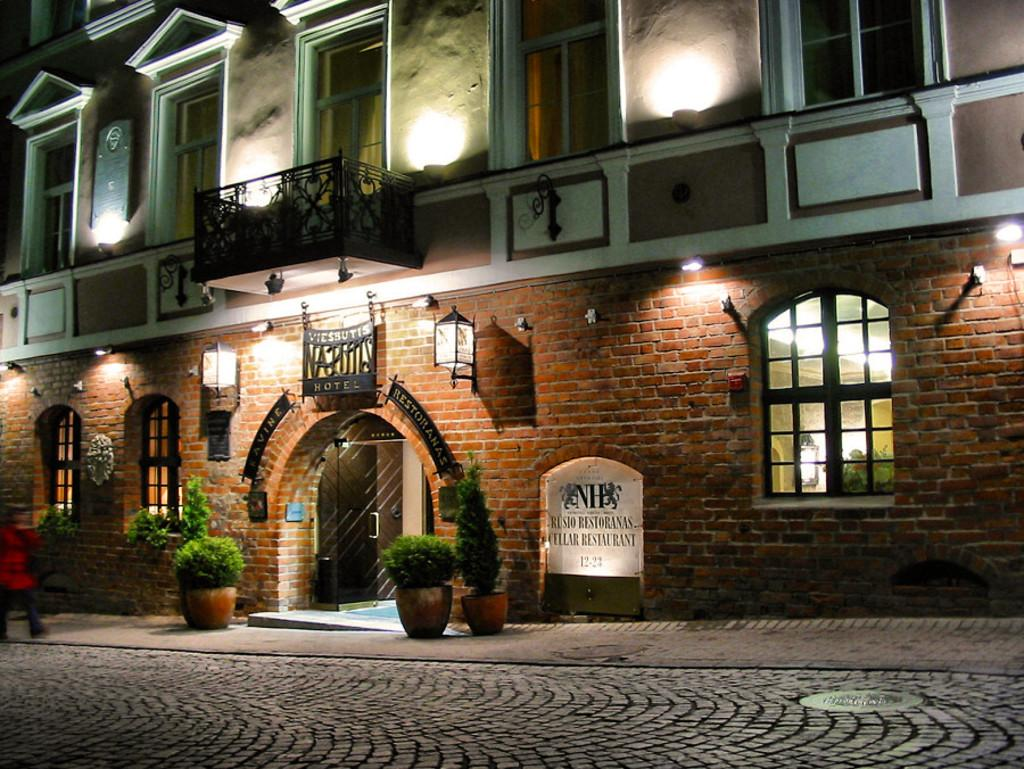<image>
Present a compact description of the photo's key features. The outside and sign for Cellar Restaurant at night. 